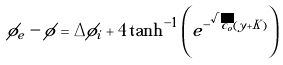<formula> <loc_0><loc_0><loc_500><loc_500>\phi _ { e } - \phi = \Delta \phi _ { i } + 4 \tanh ^ { - 1 } \left ( e ^ { - \sqrt { c _ { o } } ( y + K ) } \right )</formula> 